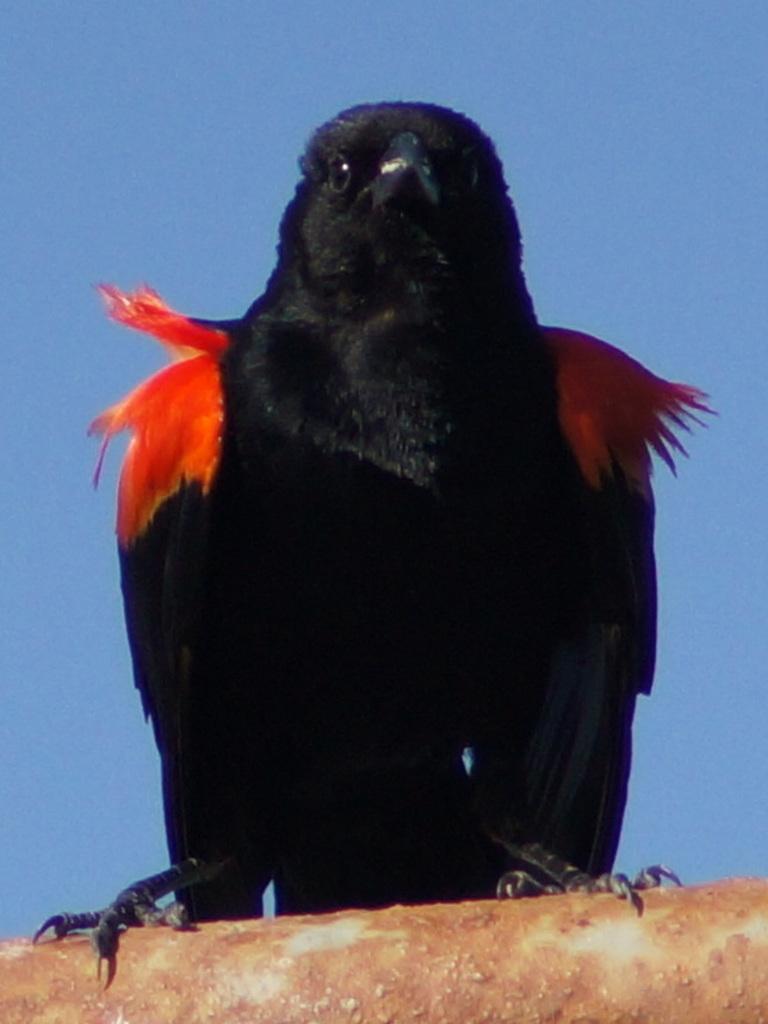In one or two sentences, can you explain what this image depicts? In this picture there is a crow who is standing on the pipe. At the top there is a sky. 